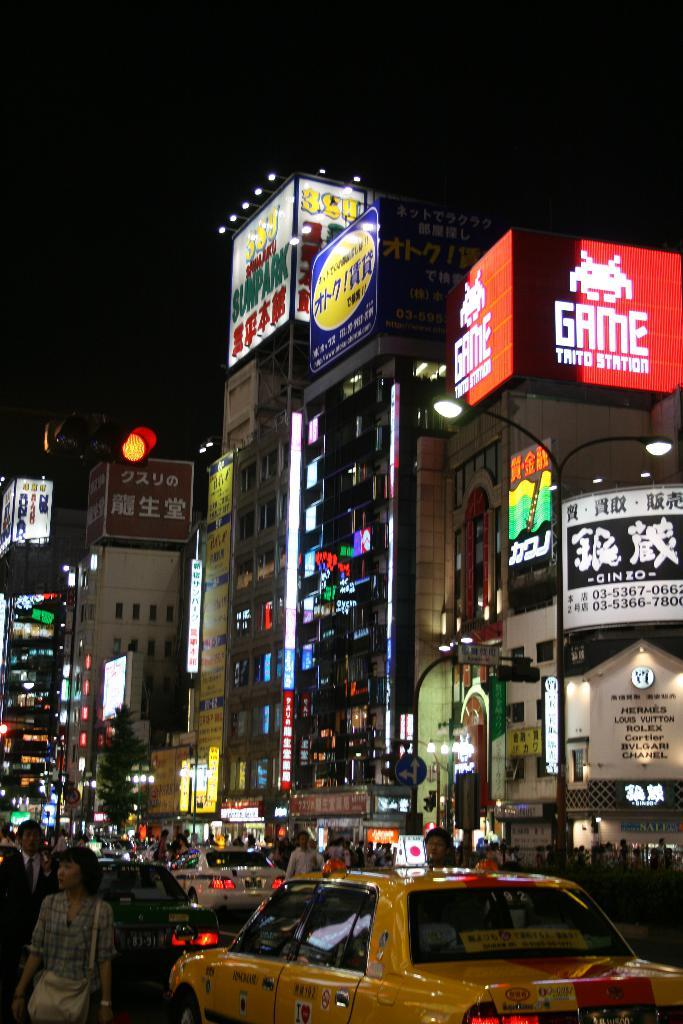<image>
Offer a succinct explanation of the picture presented. A store advertises Louis Vuitton, Rolex, Cartier and Chanel among other brands. 